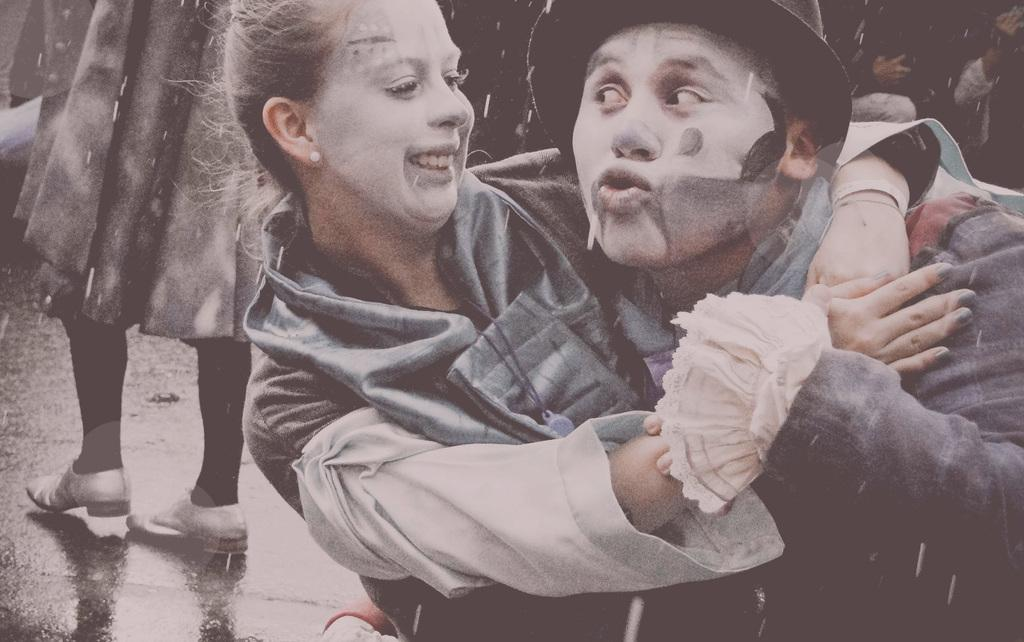Who are the two people in the foreground of the image? There is a man and a woman in the foreground of the image. What is the woman wearing on her face? The woman has makeup on her face. What are the man and woman doing in the image? The man and woman are hugging. What can be seen in the background of the image? There are people in the background of the image. Where are the people in the background located? The people are on a road. What type of button can be seen on the woman's shirt in the image? There is no button visible on the woman's shirt in the image. How many fingers does the man have on his right hand in the image? There is no way to determine the number of fingers on the man's right hand in the image, as it is not visible. 